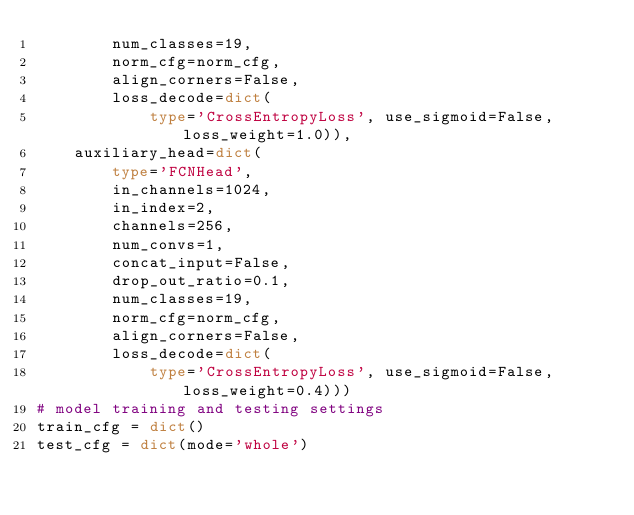Convert code to text. <code><loc_0><loc_0><loc_500><loc_500><_Python_>        num_classes=19,
        norm_cfg=norm_cfg,
        align_corners=False,
        loss_decode=dict(
            type='CrossEntropyLoss', use_sigmoid=False, loss_weight=1.0)),
    auxiliary_head=dict(
        type='FCNHead',
        in_channels=1024,
        in_index=2,
        channels=256,
        num_convs=1,
        concat_input=False,
        drop_out_ratio=0.1,
        num_classes=19,
        norm_cfg=norm_cfg,
        align_corners=False,
        loss_decode=dict(
            type='CrossEntropyLoss', use_sigmoid=False, loss_weight=0.4)))
# model training and testing settings
train_cfg = dict()
test_cfg = dict(mode='whole')
</code> 